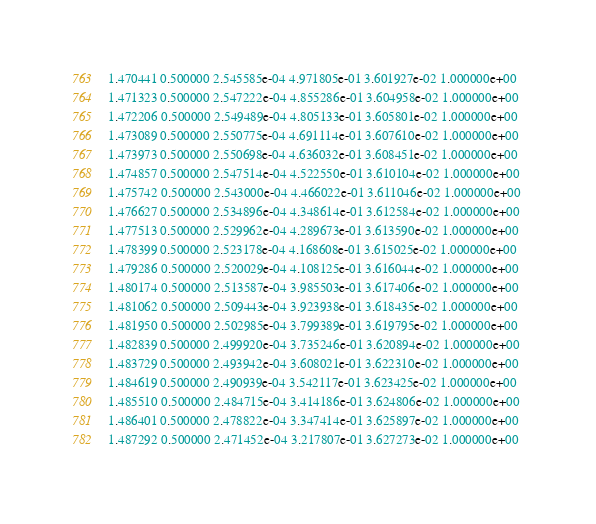Convert code to text. <code><loc_0><loc_0><loc_500><loc_500><_SQL_>1.470441 0.500000 2.545585e-04 4.971805e-01 3.601927e-02 1.000000e+00 
1.471323 0.500000 2.547222e-04 4.855286e-01 3.604958e-02 1.000000e+00 
1.472206 0.500000 2.549489e-04 4.805133e-01 3.605801e-02 1.000000e+00 
1.473089 0.500000 2.550775e-04 4.691114e-01 3.607610e-02 1.000000e+00 
1.473973 0.500000 2.550698e-04 4.636032e-01 3.608451e-02 1.000000e+00 
1.474857 0.500000 2.547514e-04 4.522550e-01 3.610104e-02 1.000000e+00 
1.475742 0.500000 2.543000e-04 4.466022e-01 3.611046e-02 1.000000e+00 
1.476627 0.500000 2.534896e-04 4.348614e-01 3.612584e-02 1.000000e+00 
1.477513 0.500000 2.529962e-04 4.289673e-01 3.613590e-02 1.000000e+00 
1.478399 0.500000 2.523178e-04 4.168608e-01 3.615025e-02 1.000000e+00 
1.479286 0.500000 2.520029e-04 4.108125e-01 3.616044e-02 1.000000e+00 
1.480174 0.500000 2.513587e-04 3.985503e-01 3.617406e-02 1.000000e+00 
1.481062 0.500000 2.509443e-04 3.923938e-01 3.618435e-02 1.000000e+00 
1.481950 0.500000 2.502985e-04 3.799389e-01 3.619795e-02 1.000000e+00 
1.482839 0.500000 2.499920e-04 3.735246e-01 3.620894e-02 1.000000e+00 
1.483729 0.500000 2.493942e-04 3.608021e-01 3.622310e-02 1.000000e+00 
1.484619 0.500000 2.490939e-04 3.542117e-01 3.623425e-02 1.000000e+00 
1.485510 0.500000 2.484715e-04 3.414186e-01 3.624806e-02 1.000000e+00 
1.486401 0.500000 2.478822e-04 3.347414e-01 3.625897e-02 1.000000e+00 
1.487292 0.500000 2.471452e-04 3.217807e-01 3.627273e-02 1.000000e+00 </code> 